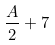Convert formula to latex. <formula><loc_0><loc_0><loc_500><loc_500>\frac { A } { 2 } + 7</formula> 